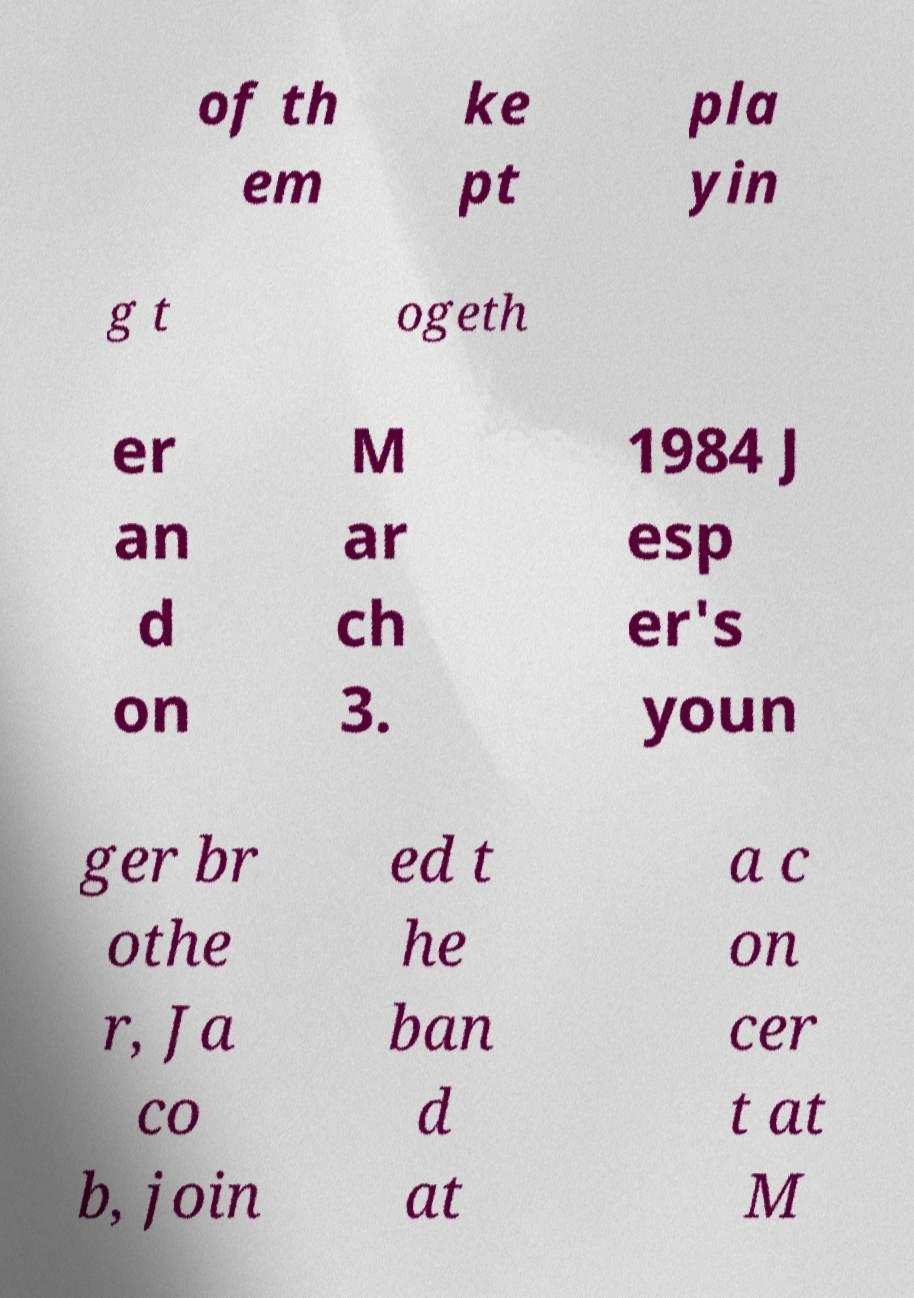I need the written content from this picture converted into text. Can you do that? of th em ke pt pla yin g t ogeth er an d on M ar ch 3. 1984 J esp er's youn ger br othe r, Ja co b, join ed t he ban d at a c on cer t at M 